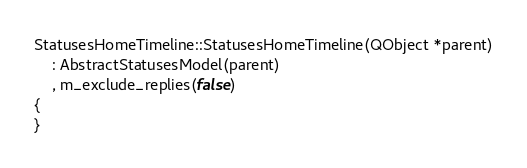Convert code to text. <code><loc_0><loc_0><loc_500><loc_500><_C++_>
StatusesHomeTimeline::StatusesHomeTimeline(QObject *parent)
    : AbstractStatusesModel(parent)
    , m_exclude_replies(false)
{
}
</code> 